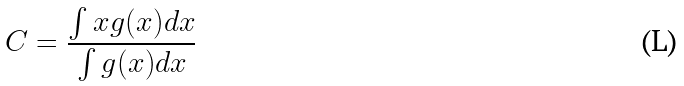Convert formula to latex. <formula><loc_0><loc_0><loc_500><loc_500>C = \frac { \int x g ( x ) d x } { \int g ( x ) d x }</formula> 